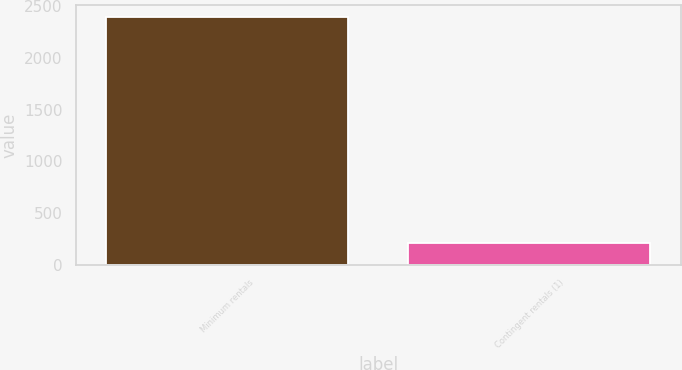Convert chart. <chart><loc_0><loc_0><loc_500><loc_500><bar_chart><fcel>Minimum rentals<fcel>Contingent rentals (1)<nl><fcel>2394<fcel>214<nl></chart> 